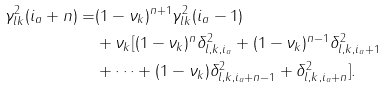Convert formula to latex. <formula><loc_0><loc_0><loc_500><loc_500>\gamma ^ { 2 } _ { l k } ( i _ { a } + n ) = & ( 1 - \nu _ { k } ) ^ { n + 1 } \gamma ^ { 2 } _ { l k } ( i _ { a } - 1 ) \\ & + \nu _ { k } [ ( 1 - \nu _ { k } ) ^ { n } \delta _ { l , k , i _ { a } } ^ { 2 } + ( 1 - \nu _ { k } ) ^ { n - 1 } \delta _ { l , k , i _ { a } + 1 } ^ { 2 } \\ & + \dots + ( 1 - \nu _ { k } ) \delta _ { l , k , i _ { a } + n - 1 } ^ { 2 } + \delta _ { l , k , i _ { a } + n } ^ { 2 } ] .</formula> 